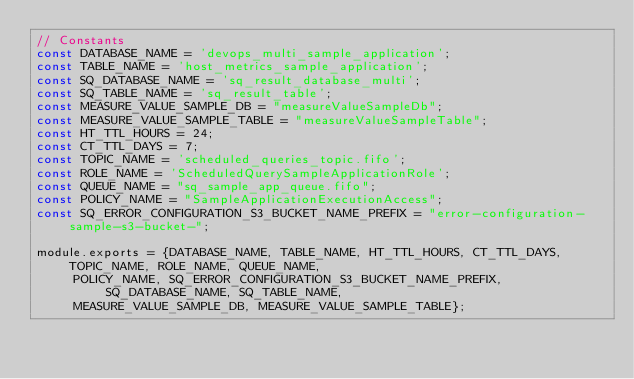<code> <loc_0><loc_0><loc_500><loc_500><_JavaScript_>// Constants
const DATABASE_NAME = 'devops_multi_sample_application';
const TABLE_NAME = 'host_metrics_sample_application';
const SQ_DATABASE_NAME = 'sq_result_database_multi';
const SQ_TABLE_NAME = 'sq_result_table';
const MEASURE_VALUE_SAMPLE_DB = "measureValueSampleDb";
const MEASURE_VALUE_SAMPLE_TABLE = "measureValueSampleTable";
const HT_TTL_HOURS = 24;
const CT_TTL_DAYS = 7;
const TOPIC_NAME = 'scheduled_queries_topic.fifo';
const ROLE_NAME = 'ScheduledQuerySampleApplicationRole';
const QUEUE_NAME = "sq_sample_app_queue.fifo";
const POLICY_NAME = "SampleApplicationExecutionAccess";
const SQ_ERROR_CONFIGURATION_S3_BUCKET_NAME_PREFIX = "error-configuration-sample-s3-bucket-";

module.exports = {DATABASE_NAME, TABLE_NAME, HT_TTL_HOURS, CT_TTL_DAYS, TOPIC_NAME, ROLE_NAME, QUEUE_NAME,
     POLICY_NAME, SQ_ERROR_CONFIGURATION_S3_BUCKET_NAME_PREFIX, SQ_DATABASE_NAME, SQ_TABLE_NAME,
     MEASURE_VALUE_SAMPLE_DB, MEASURE_VALUE_SAMPLE_TABLE};</code> 